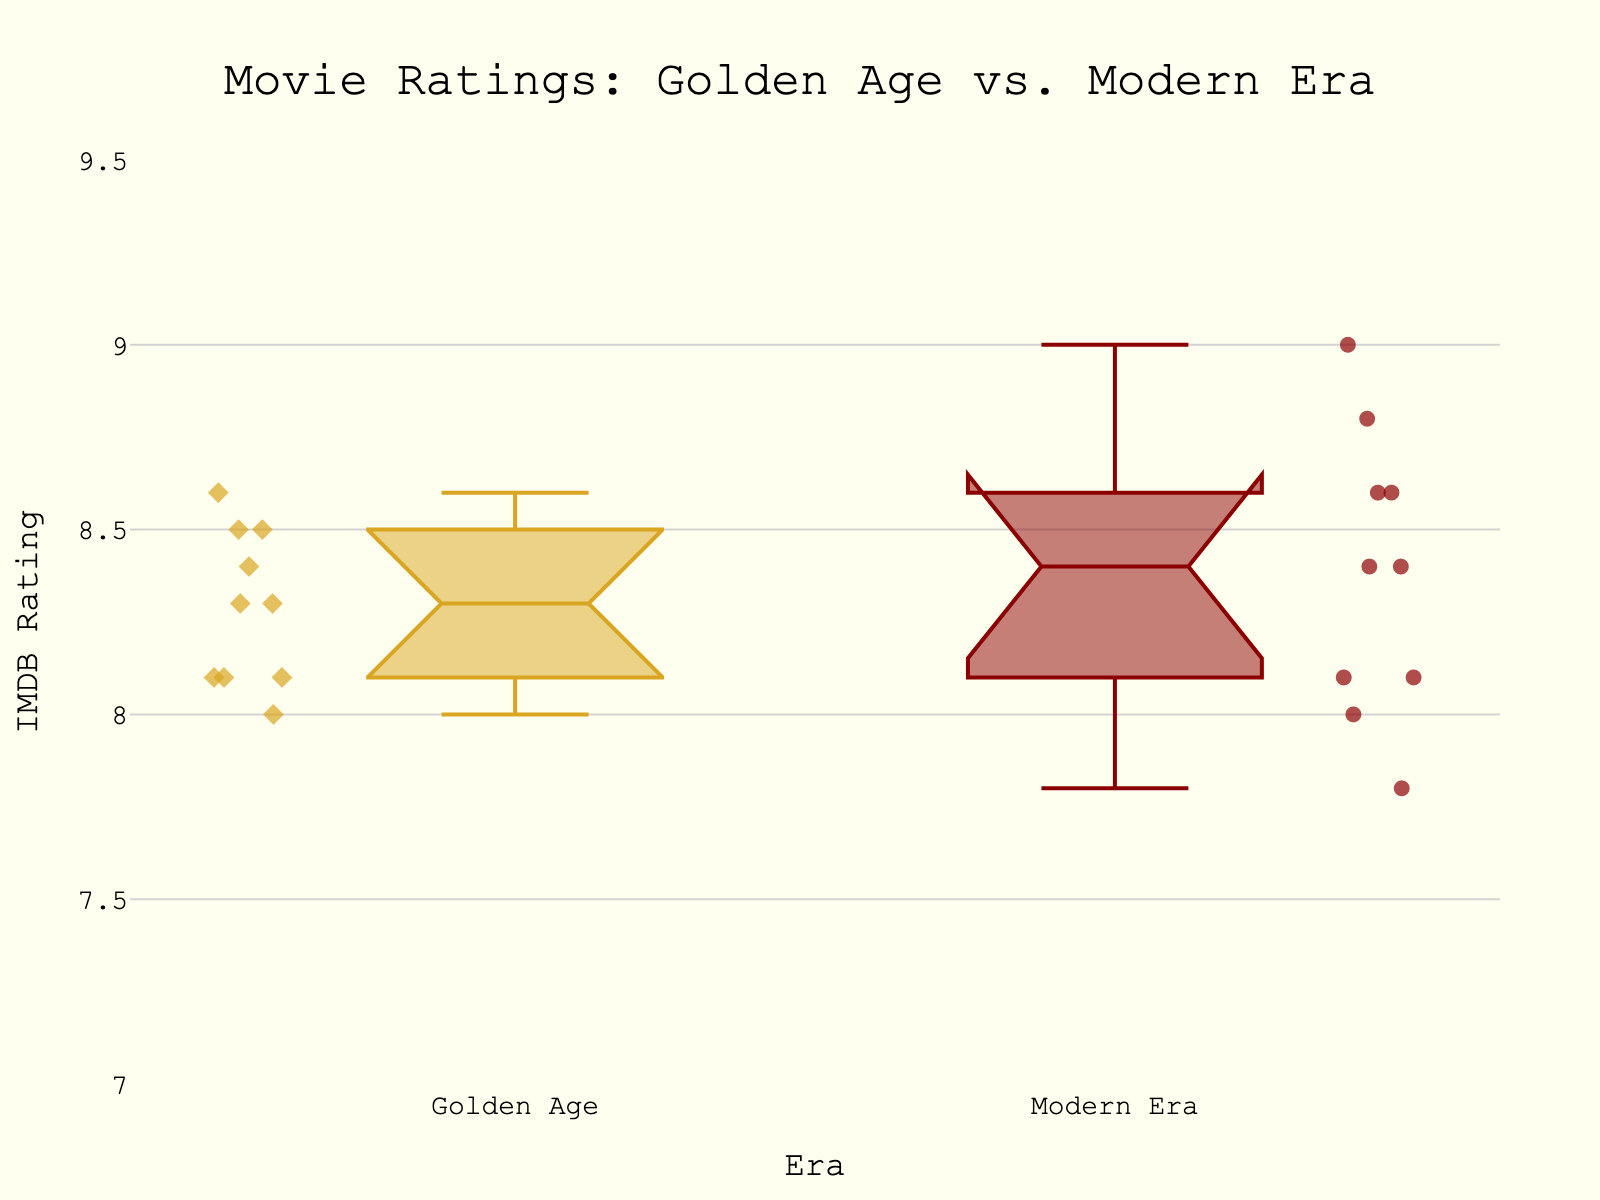What's the title of the plot? The title of the plot is displayed at the top of the figure as "Movie Ratings: Golden Age vs. Modern Era."
Answer: Movie Ratings: Golden Age vs. Modern Era What color is used to represent the movies from the Golden Age? The color used to represent the Golden Age movies is goldenrod, visible in the legend or directly on the notched box representing this era.
Answer: goldenrod Which era has the higher median IMDB rating? By observing the notches of the box plots, the Modern Era appears to have a higher median IMDB rating since its notch is positioned slightly higher than that of the Golden Age.
Answer: Modern Era What is the range of IMDB ratings shown on the y-axis? The y-axis range for IMDB ratings is marked from 7 to 9.5, as indicated by the axis ticks and labels.
Answer: 7 to 9.5 How does the spread of IMDB ratings for the Modern Era compare to the Golden Age? The spread (interquartile range) of the Modern Era's IMDB ratings seems to be slightly smaller than that of the Golden Age, implying more consistency in ratings. This can be seen from the height of the box.
Answer: Modern Era has a smaller spread How many data points are there in each era? Counting the individual markers within each notched box indicates each era has ten data points.
Answer: Ten for each Do any movies from the Golden Age have an IMDB rating below 8.0? No, there are no individual markers (data points) for the Golden Age below the 8.0 mark visible on the plot.
Answer: No What is the highest IMDB rating observed in the Modern Era? The highest IMDB rating in the Modern Era is 9.0, which corresponds to "The Dark Knight."
Answer: 9.0 Are there any overlaps between the rating distributions of the two eras? The notches of the two boxes overlap, suggesting that the medians of the two eras are not significantly different. This is a characteristic feature of notched box plots to show this overlap.
Answer: Yes Which era shows a higher variability in IMDB ratings? The Golden Age shows a higher variability in IMDB ratings as its interquartile range (height of the box) is larger and it has more spread-out data points compared to the Modern Era.
Answer: Golden Age 